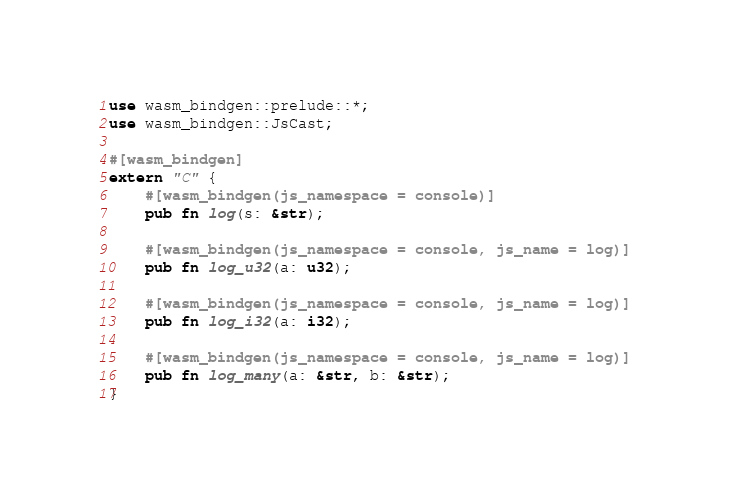Convert code to text. <code><loc_0><loc_0><loc_500><loc_500><_Rust_>use wasm_bindgen::prelude::*;
use wasm_bindgen::JsCast;

#[wasm_bindgen]
extern "C" {
    #[wasm_bindgen(js_namespace = console)]
    pub fn log(s: &str);

    #[wasm_bindgen(js_namespace = console, js_name = log)]
    pub fn log_u32(a: u32);

    #[wasm_bindgen(js_namespace = console, js_name = log)]
    pub fn log_i32(a: i32);

    #[wasm_bindgen(js_namespace = console, js_name = log)]
    pub fn log_many(a: &str, b: &str);
}
</code> 